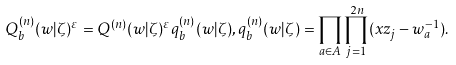<formula> <loc_0><loc_0><loc_500><loc_500>Q _ { b } ^ { ( n ) } ( w | \zeta ) ^ { \varepsilon } = Q ^ { ( n ) } ( w | \zeta ) ^ { \varepsilon } q _ { b } ^ { ( n ) } ( w | \zeta ) , q _ { b } ^ { ( n ) } ( w | \zeta ) = \prod _ { a \in A } \prod _ { j = 1 } ^ { 2 n } ( x z _ { j } - w _ { a } ^ { - 1 } ) .</formula> 